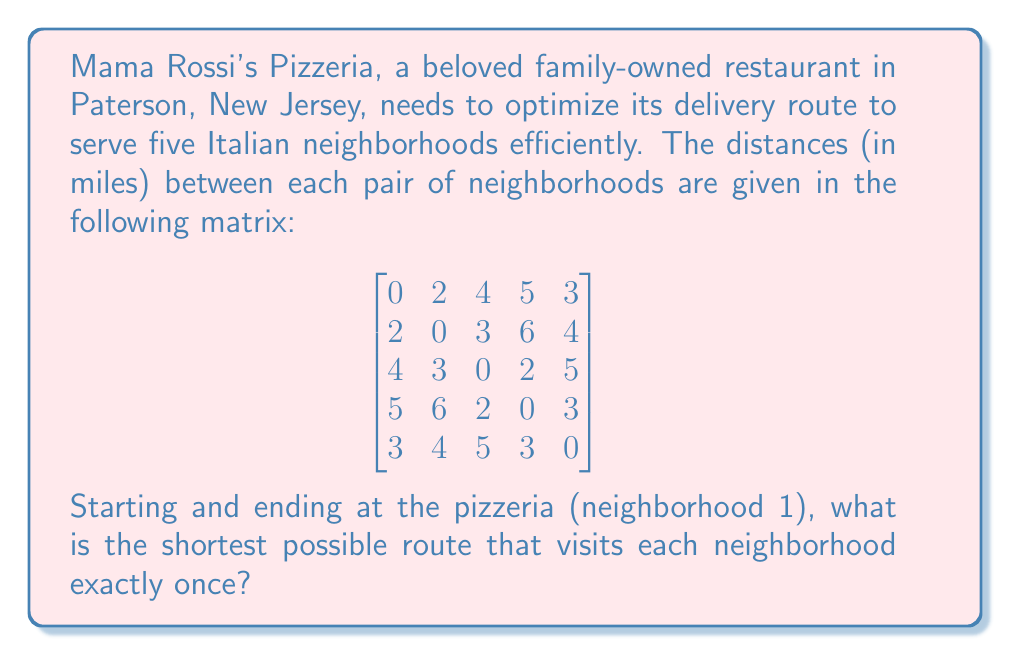Show me your answer to this math problem. To solve this problem, we'll use the Held-Karp algorithm, which is an efficient method for solving the Traveling Salesman Problem (TSP) for a small number of nodes.

Step 1: Initialize the base cases for subproblems with 2 nodes.
For each pair of nodes $(i, j)$ where $i \neq 1$ and $j \neq i$:
$C(\{i\}, i) = \text{distance}(1, i)$

Step 2: Iterate through subsets of increasing size (from 2 to n-1).
For each subset $S \subseteq \{2, 3, 4, 5\}$ and each $j \in S$:
$C(S, j) = \min_{i \in S, i \neq j} \{C(S - \{j\}, i) + \text{distance}(i, j)\}$

Step 3: Compute the final solution.
$\text{optimal\_cost} = \min_{j \neq 1} \{C(\{2, 3, 4, 5\}, j) + \text{distance}(j, 1)\}$

Step 4: Reconstruct the optimal path.

Applying this algorithm to our problem:

Base cases:
$C(\{2\}, 2) = 2$, $C(\{3\}, 3) = 4$, $C(\{4\}, 4) = 5$, $C(\{5\}, 5) = 3$

Subsets of size 2:
$C(\{2,3\}, 2) = 7$, $C(\{2,3\}, 3) = 6$
$C(\{2,4\}, 2) = 11$, $C(\{2,4\}, 4) = 8$
$C(\{2,5\}, 2) = 7$, $C(\{2,5\}, 5) = 6$
$C(\{3,4\}, 3) = 7$, $C(\{3,4\}, 4) = 6$
$C(\{3,5\}, 3) = 9$, $C(\{3,5\}, 5) = 9$
$C(\{4,5\}, 4) = 8$, $C(\{4,5\}, 5) = 8$

Subsets of size 3:
$C(\{2,3,4\}, 2) = 11$, $C(\{2,3,4\}, 3) = 10$, $C(\{2,3,4\}, 4) = 9$
$C(\{2,3,5\}, 2) = 11$, $C(\{2,3,5\}, 3) = 11$, $C(\{2,3,5\}, 5) = 10$
$C(\{2,4,5\}, 2) = 12$, $C(\{2,4,5\}, 4) = 11$, $C(\{2,4,5\}, 5) = 11$
$C(\{3,4,5\}, 3) = 12$, $C(\{3,4,5\}, 4) = 11$, $C(\{3,4,5\}, 5) = 12$

Subset of size 4:
$C(\{2,3,4,5\}, 2) = 15$, $C(\{2,3,4,5\}, 3) = 14$, $C(\{2,3,4,5\}, 4) = 13$, $C(\{2,3,4,5\}, 5) = 14$

Final solution:
$\text{optimal\_cost} = \min\{15 + 2, 14 + 4, 13 + 5, 14 + 3\} = 17$

Reconstructing the path:
1 → 2 → 3 → 4 → 5 → 1

Therefore, the shortest route is: Pizzeria (1) → Neighborhood 2 → Neighborhood 3 → Neighborhood 4 → Neighborhood 5 → Pizzeria (1), with a total distance of 17 miles.
Answer: The shortest possible route is 1 → 2 → 3 → 4 → 5 → 1, with a total distance of 17 miles. 